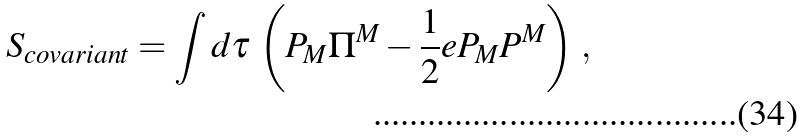Convert formula to latex. <formula><loc_0><loc_0><loc_500><loc_500>S _ { c o v a r i a n t } = \int d \tau \, \left ( P _ { M } \Pi ^ { M } - \frac { 1 } { 2 } e P _ { M } P ^ { M } \right ) \, ,</formula> 